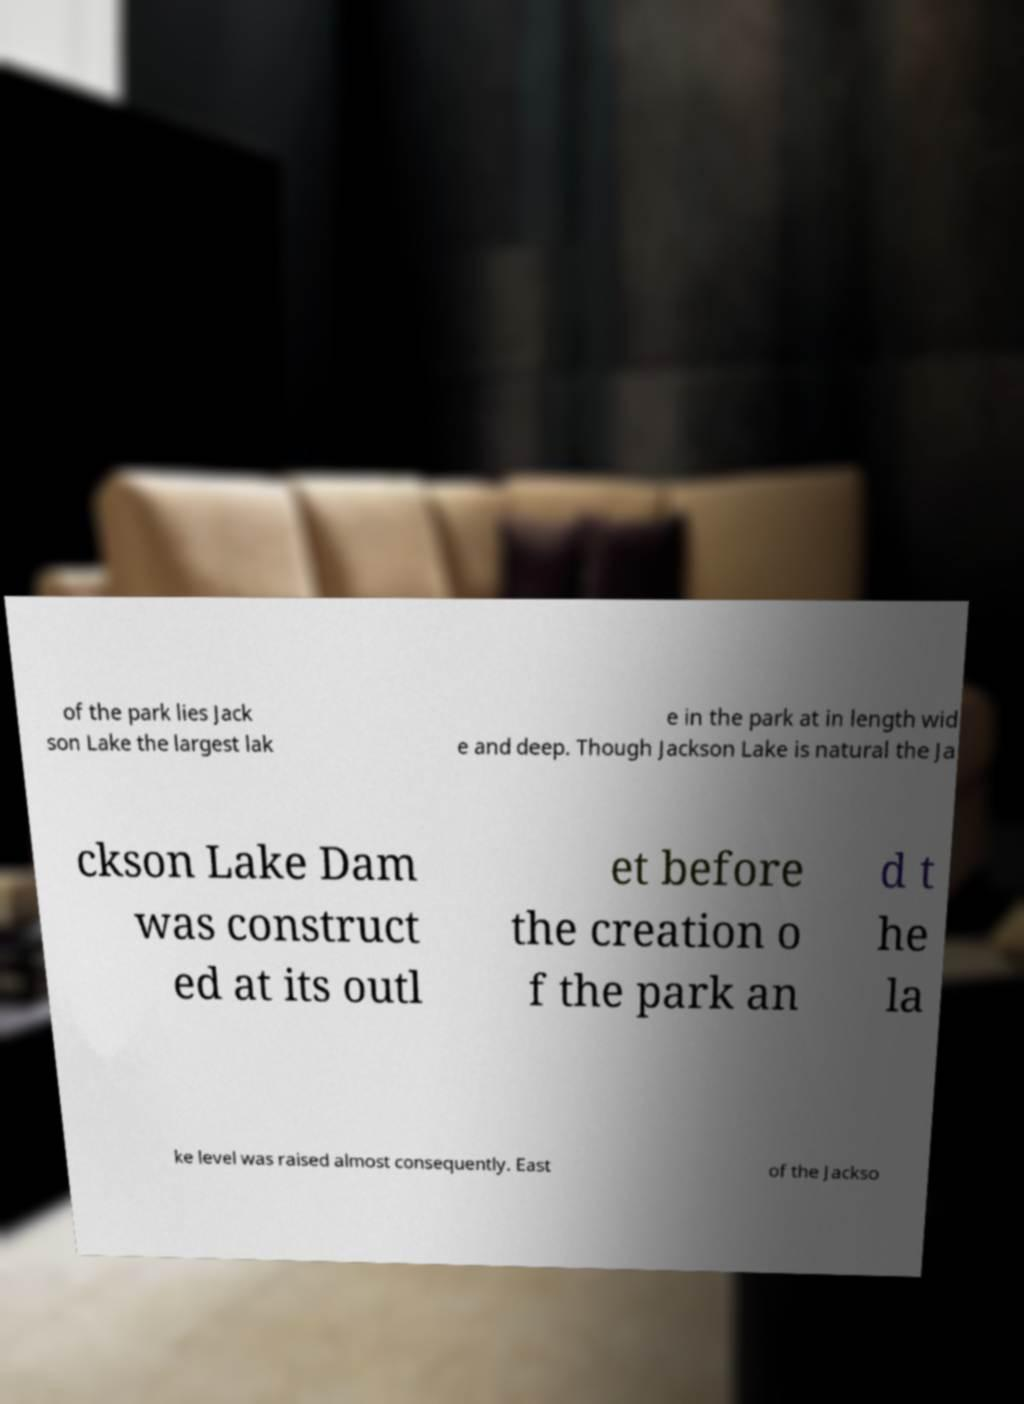For documentation purposes, I need the text within this image transcribed. Could you provide that? of the park lies Jack son Lake the largest lak e in the park at in length wid e and deep. Though Jackson Lake is natural the Ja ckson Lake Dam was construct ed at its outl et before the creation o f the park an d t he la ke level was raised almost consequently. East of the Jackso 